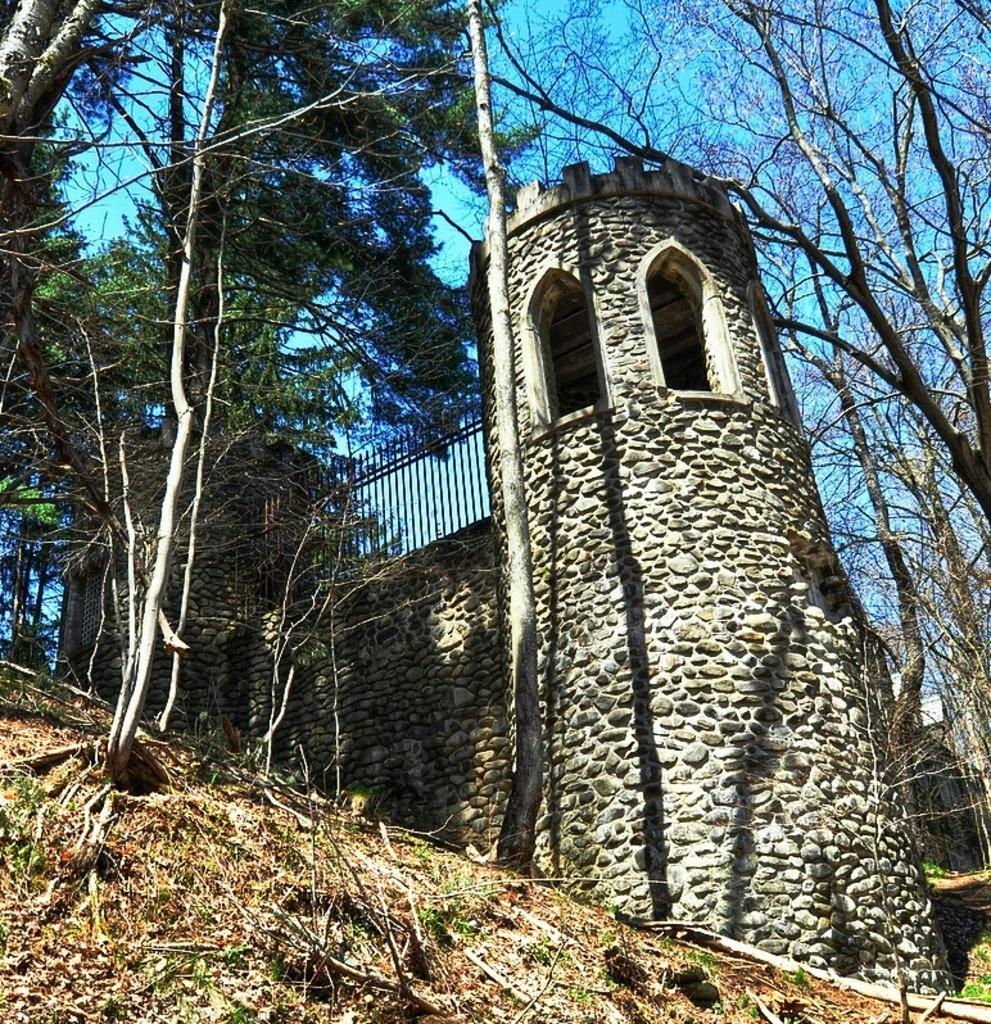What type of natural elements can be seen in the image? There are trees in the image. What type of man-made structures are present in the image? There are buildings in the image. What is present on the surface at the bottom of the image? Dried leaves are present on the surface at the bottom of the image. What is visible at the top of the image? The sky is visible at the top of the image. What type of force is being exerted on the trees in the image? There is no indication of any force being exerted on the trees in the image. What type of jewel can be seen hanging from the branches of the trees in the image? There are no jewels present in the image; only trees, buildings, dried leaves, and the sky are visible. 